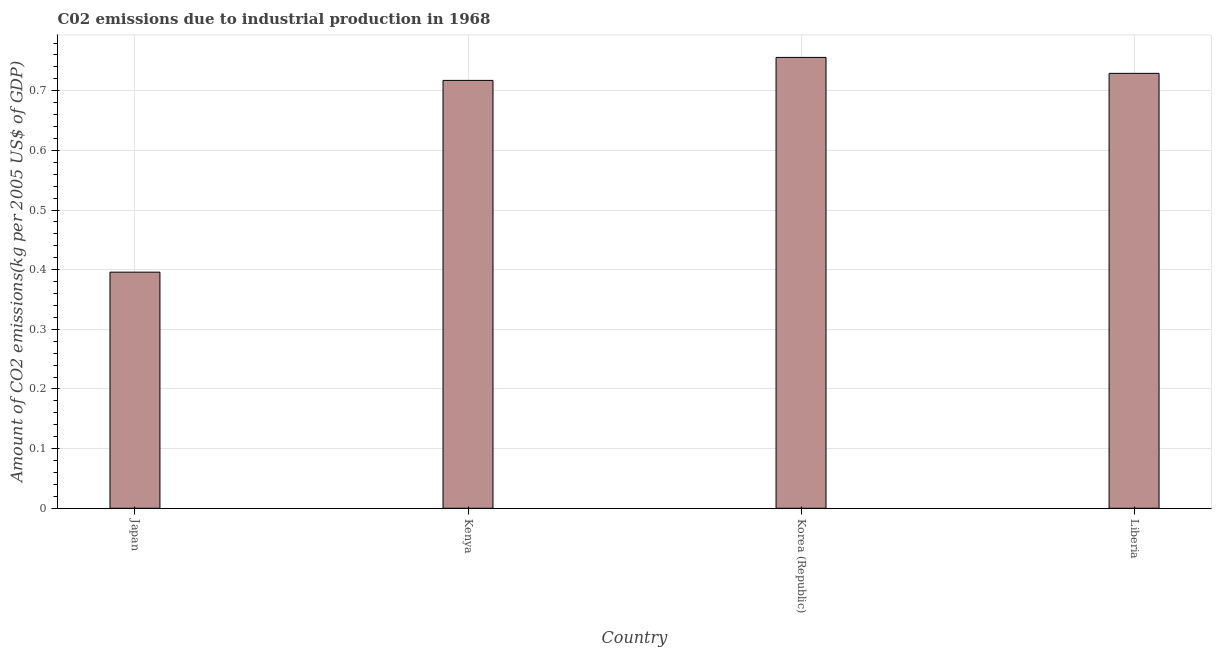What is the title of the graph?
Your response must be concise. C02 emissions due to industrial production in 1968. What is the label or title of the X-axis?
Keep it short and to the point. Country. What is the label or title of the Y-axis?
Offer a terse response. Amount of CO2 emissions(kg per 2005 US$ of GDP). What is the amount of co2 emissions in Korea (Republic)?
Offer a very short reply. 0.76. Across all countries, what is the maximum amount of co2 emissions?
Your answer should be compact. 0.76. Across all countries, what is the minimum amount of co2 emissions?
Your response must be concise. 0.4. In which country was the amount of co2 emissions minimum?
Offer a terse response. Japan. What is the sum of the amount of co2 emissions?
Offer a very short reply. 2.6. What is the difference between the amount of co2 emissions in Japan and Kenya?
Make the answer very short. -0.32. What is the average amount of co2 emissions per country?
Your answer should be very brief. 0.65. What is the median amount of co2 emissions?
Offer a very short reply. 0.72. What is the ratio of the amount of co2 emissions in Korea (Republic) to that in Liberia?
Give a very brief answer. 1.04. Is the difference between the amount of co2 emissions in Korea (Republic) and Liberia greater than the difference between any two countries?
Keep it short and to the point. No. What is the difference between the highest and the second highest amount of co2 emissions?
Give a very brief answer. 0.03. Is the sum of the amount of co2 emissions in Japan and Kenya greater than the maximum amount of co2 emissions across all countries?
Provide a short and direct response. Yes. What is the difference between the highest and the lowest amount of co2 emissions?
Give a very brief answer. 0.36. How many bars are there?
Provide a short and direct response. 4. How many countries are there in the graph?
Offer a very short reply. 4. What is the Amount of CO2 emissions(kg per 2005 US$ of GDP) in Japan?
Provide a succinct answer. 0.4. What is the Amount of CO2 emissions(kg per 2005 US$ of GDP) of Kenya?
Your answer should be very brief. 0.72. What is the Amount of CO2 emissions(kg per 2005 US$ of GDP) in Korea (Republic)?
Ensure brevity in your answer.  0.76. What is the Amount of CO2 emissions(kg per 2005 US$ of GDP) of Liberia?
Keep it short and to the point. 0.73. What is the difference between the Amount of CO2 emissions(kg per 2005 US$ of GDP) in Japan and Kenya?
Offer a terse response. -0.32. What is the difference between the Amount of CO2 emissions(kg per 2005 US$ of GDP) in Japan and Korea (Republic)?
Offer a terse response. -0.36. What is the difference between the Amount of CO2 emissions(kg per 2005 US$ of GDP) in Japan and Liberia?
Your response must be concise. -0.33. What is the difference between the Amount of CO2 emissions(kg per 2005 US$ of GDP) in Kenya and Korea (Republic)?
Provide a succinct answer. -0.04. What is the difference between the Amount of CO2 emissions(kg per 2005 US$ of GDP) in Kenya and Liberia?
Offer a terse response. -0.01. What is the difference between the Amount of CO2 emissions(kg per 2005 US$ of GDP) in Korea (Republic) and Liberia?
Your answer should be very brief. 0.03. What is the ratio of the Amount of CO2 emissions(kg per 2005 US$ of GDP) in Japan to that in Kenya?
Provide a succinct answer. 0.55. What is the ratio of the Amount of CO2 emissions(kg per 2005 US$ of GDP) in Japan to that in Korea (Republic)?
Give a very brief answer. 0.52. What is the ratio of the Amount of CO2 emissions(kg per 2005 US$ of GDP) in Japan to that in Liberia?
Offer a terse response. 0.54. What is the ratio of the Amount of CO2 emissions(kg per 2005 US$ of GDP) in Kenya to that in Korea (Republic)?
Offer a terse response. 0.95. What is the ratio of the Amount of CO2 emissions(kg per 2005 US$ of GDP) in Kenya to that in Liberia?
Provide a short and direct response. 0.98. 